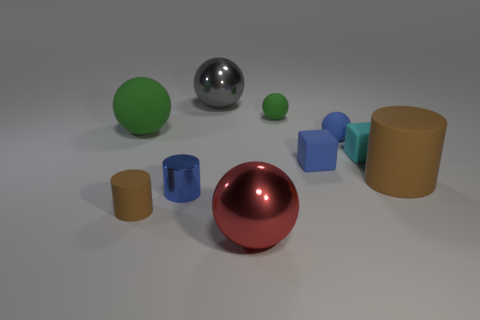What is the size of the gray shiny thing?
Your answer should be very brief. Large. What material is the blue block that is the same size as the blue cylinder?
Provide a succinct answer. Rubber. There is a gray metallic sphere; what number of cylinders are on the right side of it?
Ensure brevity in your answer.  1. Do the tiny cylinder that is to the left of the blue cylinder and the blue thing that is left of the large red metallic thing have the same material?
Offer a terse response. No. The large rubber object that is to the left of the big metal thing that is in front of the large matte thing that is on the left side of the large brown matte cylinder is what shape?
Provide a short and direct response. Sphere. The tiny green rubber thing is what shape?
Provide a short and direct response. Sphere. What shape is the brown thing that is the same size as the cyan rubber block?
Make the answer very short. Cylinder. What number of other objects are the same color as the large matte cylinder?
Provide a short and direct response. 1. There is a small object that is behind the big green matte object; is it the same shape as the big shiny thing that is in front of the large green matte sphere?
Your answer should be compact. Yes. How many things are either balls right of the red thing or big red shiny things that are in front of the tiny green rubber ball?
Keep it short and to the point. 3. 